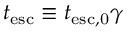<formula> <loc_0><loc_0><loc_500><loc_500>t _ { e s c } \equiv t _ { e s c , 0 } \gamma</formula> 